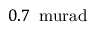Convert formula to latex. <formula><loc_0><loc_0><loc_500><loc_500>0 . 7 \, \ m u r a d</formula> 